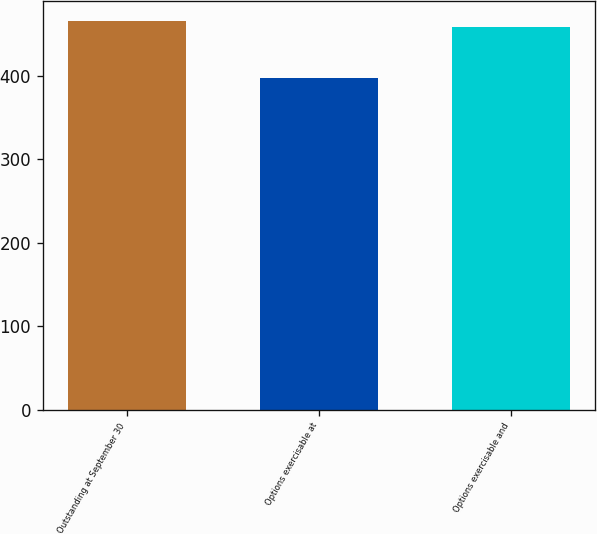Convert chart. <chart><loc_0><loc_0><loc_500><loc_500><bar_chart><fcel>Outstanding at September 30<fcel>Options exercisable at<fcel>Options exercisable and<nl><fcel>466<fcel>397<fcel>459<nl></chart> 